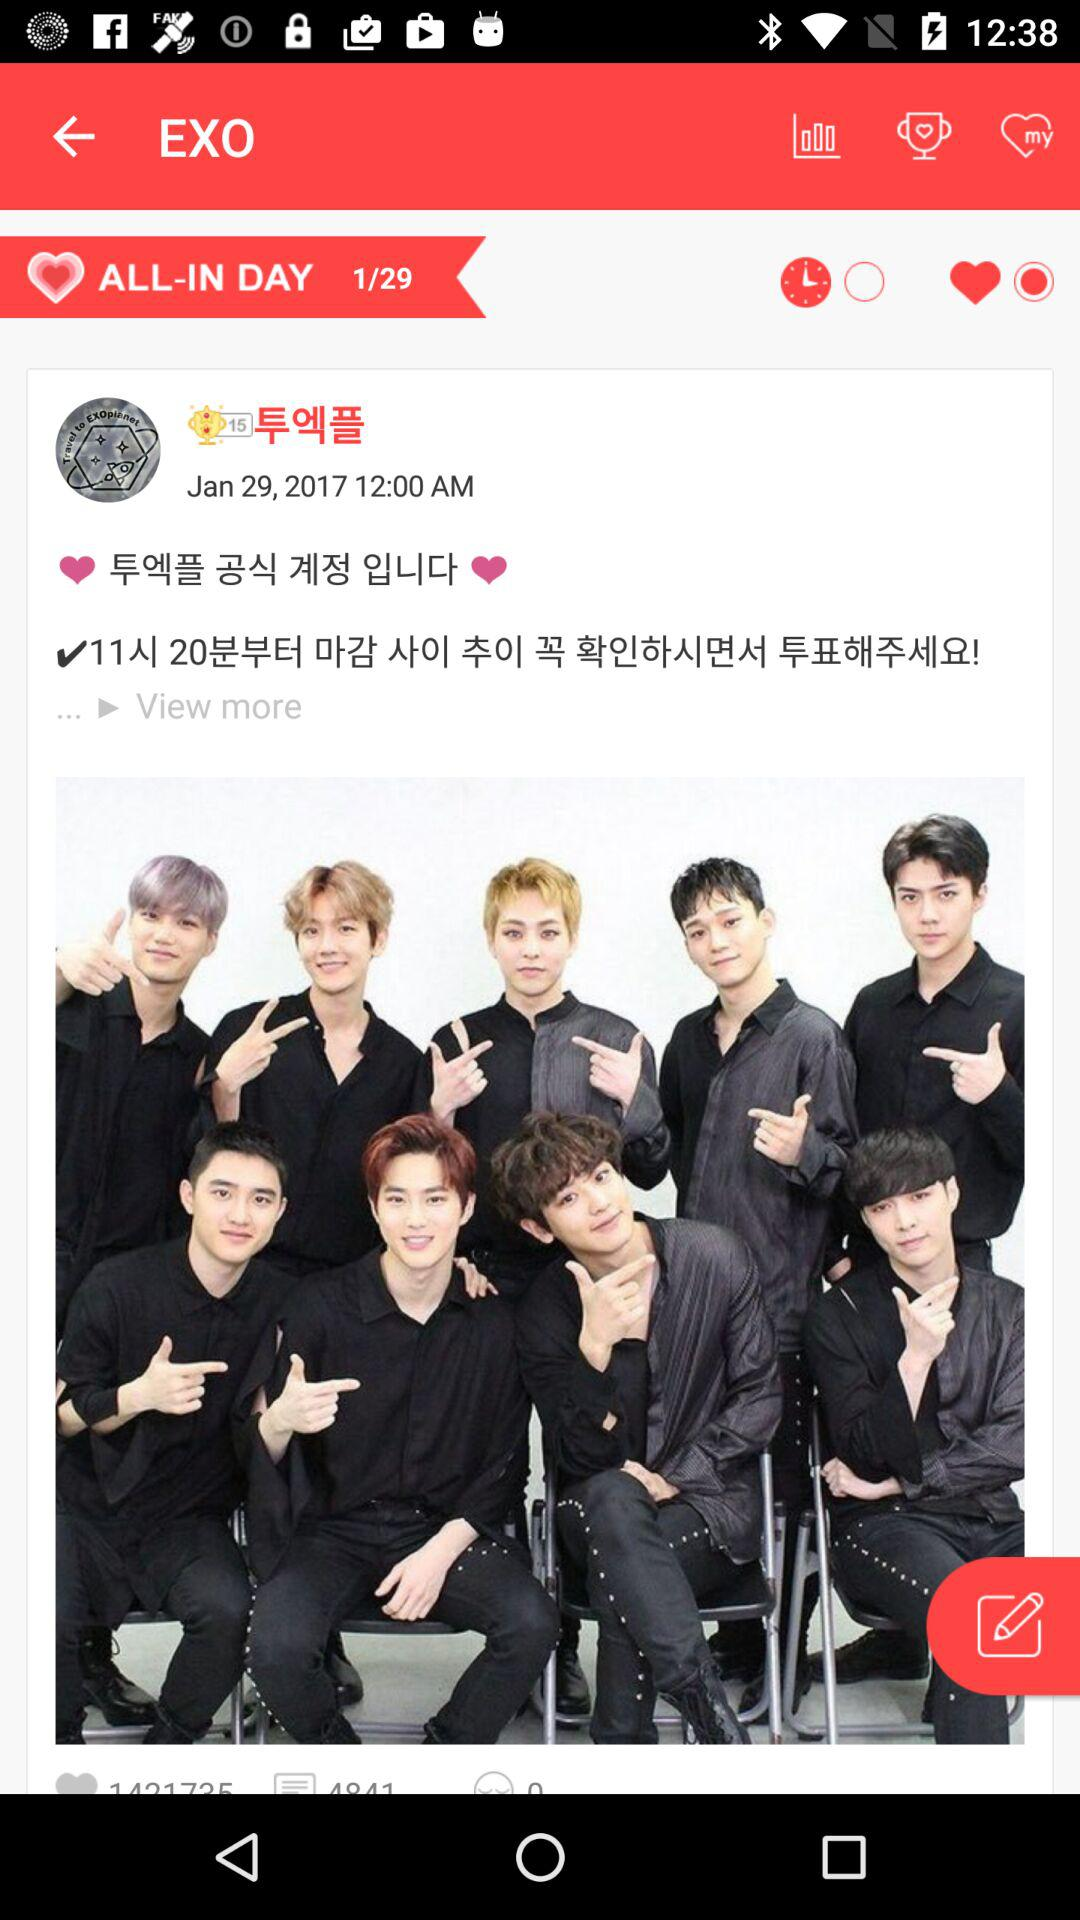At which current post am I? You are currently at post 1. 